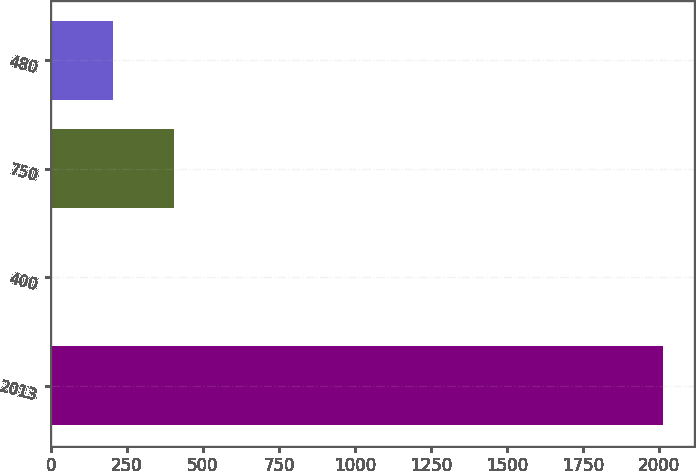Convert chart. <chart><loc_0><loc_0><loc_500><loc_500><bar_chart><fcel>2013<fcel>400<fcel>750<fcel>480<nl><fcel>2013<fcel>4<fcel>405.8<fcel>204.9<nl></chart> 